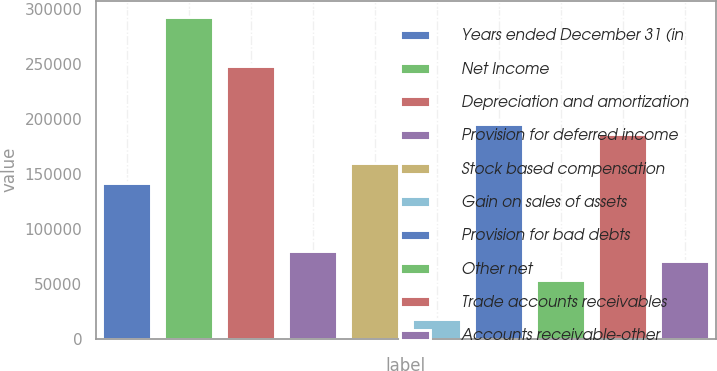Convert chart to OTSL. <chart><loc_0><loc_0><loc_500><loc_500><bar_chart><fcel>Years ended December 31 (in<fcel>Net Income<fcel>Depreciation and amortization<fcel>Provision for deferred income<fcel>Stock based compensation<fcel>Gain on sales of assets<fcel>Provision for bad debts<fcel>Other net<fcel>Trade accounts receivables<fcel>Accounts receivable-other<nl><fcel>142006<fcel>292864<fcel>248494<fcel>79888<fcel>159754<fcel>17770<fcel>195250<fcel>53266<fcel>186376<fcel>71014<nl></chart> 